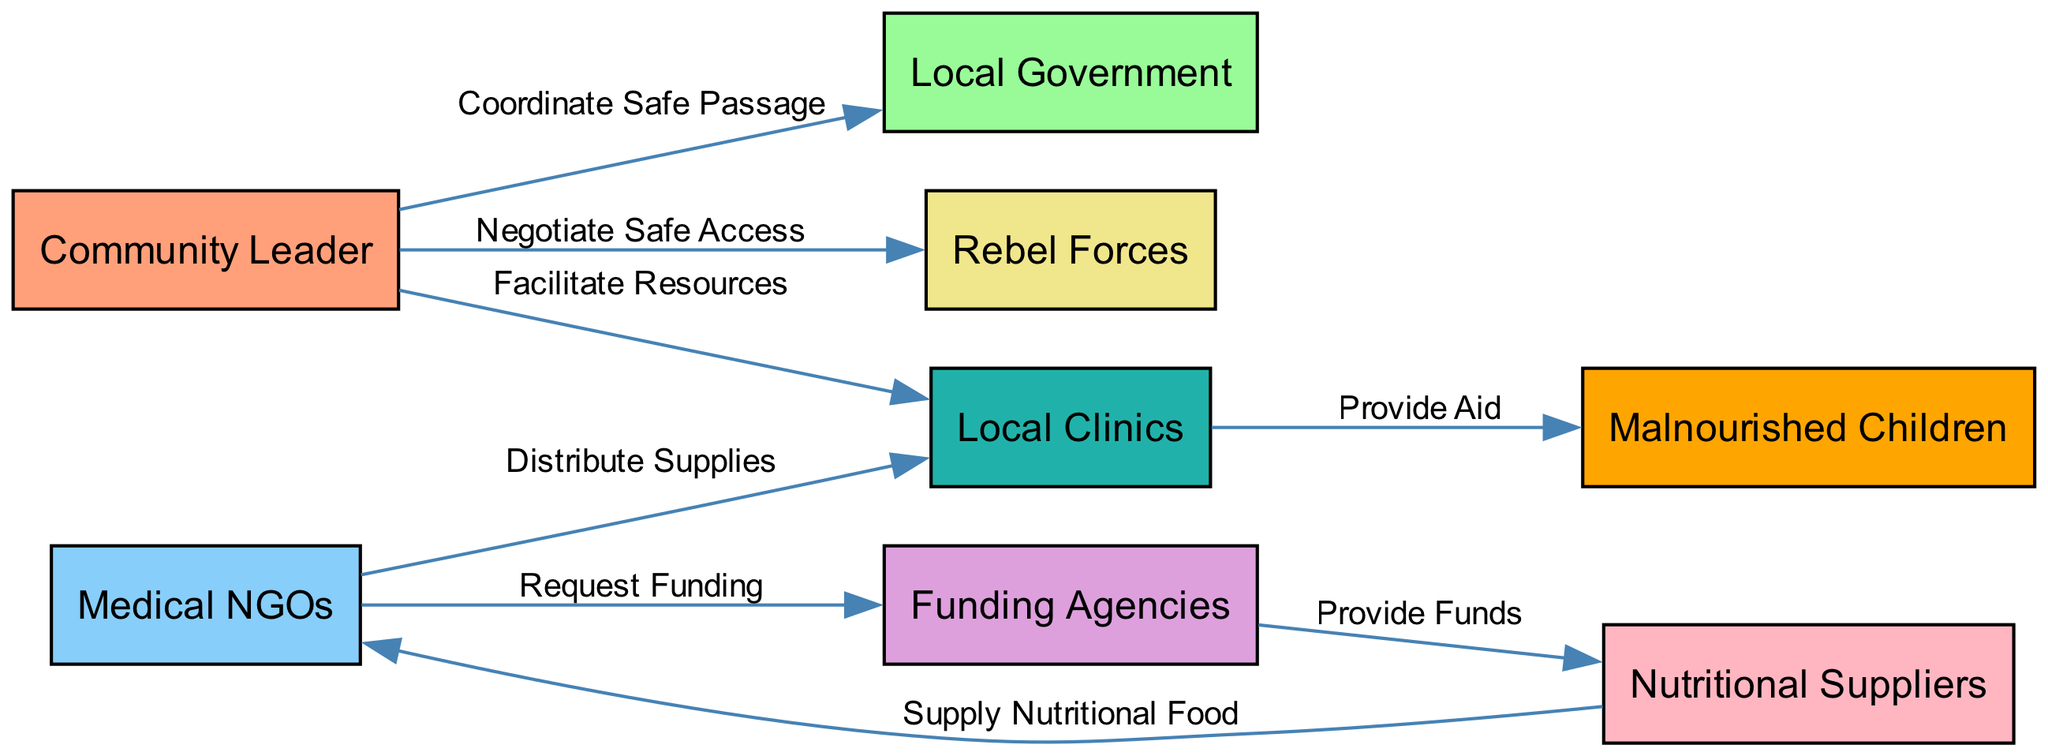What is the total number of nodes in the diagram? The diagram has eight nodes: Community Leader, Local Government, Rebel Forces, Medical NGOs, Funding Agencies, Nutritional Suppliers, Local Clinics, and Malnourished Children. To find the total, we can simply count these unique nodes.
Answer: eight What role does the Community Leader play in relation to the Local Clinics? In the diagram, the Community Leader facilitates resources for the Local Clinics. This is shown by the directed edge from Community Leader to Local Clinics labeled "Facilitate Resources."
Answer: Facilitate Resources How many edges are present in the diagram? The diagram contains seven edges, which represent the connections and relationships between the different nodes. Each edge signifies a specific action or relationship, and they can be counted directly from the visual representation.
Answer: seven Which node receives supplies from the Nutritional Suppliers? The Nutritional Suppliers supply nutritional food to the Medical NGOs, as indicated by the directed edge labeled "Supply Nutritional Food," flowing from Nutritional Suppliers to Medical NGOs.
Answer: Medical NGOs What is the connection between Funding Agencies and Nutritional Suppliers? The Funding Agencies provide funds to Nutritional Suppliers. This is depicted by the edge labeled "Provide Funds" directed from Funding Agencies to Nutritional Suppliers.
Answer: Provide Funds What type of aid do Local Clinics provide to Malnourished Children? Local Clinics provide aid to Malnourished Children, as illustrated by the directed edge from Local Clinics to Malnourished Children, which is labeled "Provide Aid."
Answer: Provide Aid Who is responsible for negotiating safe access to the area? The Community Leader is responsible for negotiating safe access, as shown in the diagram by the directed edge to Rebel Forces labeled "Negotiate Safe Access."
Answer: Community Leader What is the pathway for Nutritional Food to reach Malnourished Children? Nutritional Food flows from Nutritional Suppliers to Medical NGOs, which then distribute the supplies to Local Clinics that provide aid to Malnourished Children. This requires following the directed edges in sequence: Nutritional Suppliers → Medical NGOs → Local Clinics → Malnourished Children.
Answer: Nutritional Suppliers → Medical NGOs → Local Clinics → Malnourished Children 